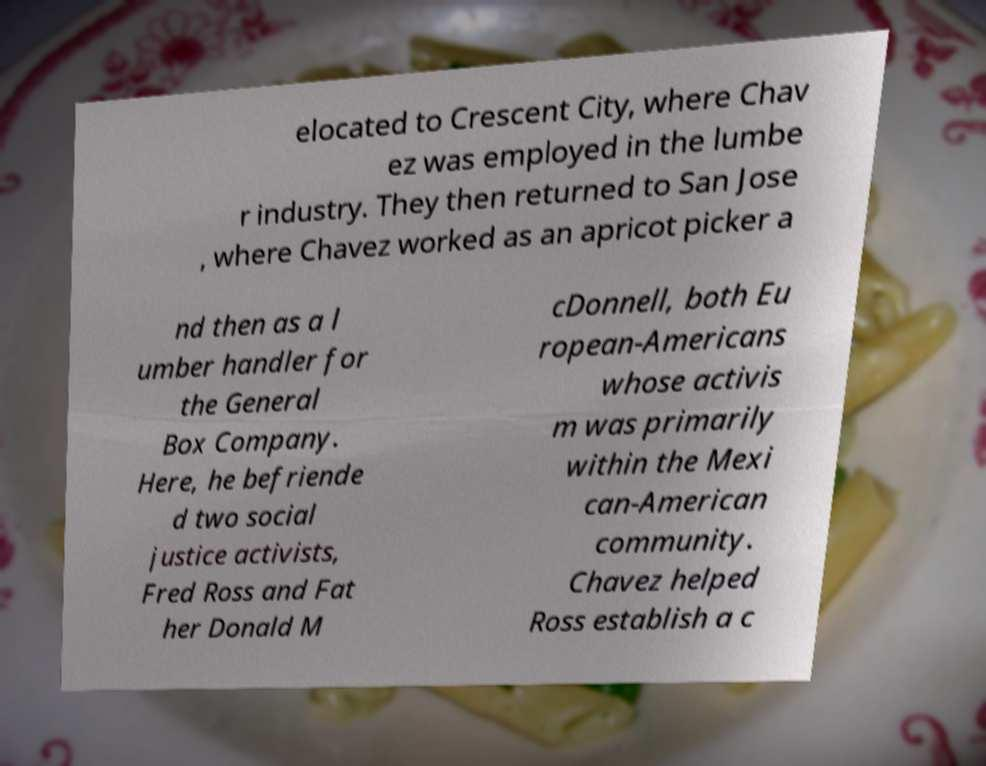For documentation purposes, I need the text within this image transcribed. Could you provide that? elocated to Crescent City, where Chav ez was employed in the lumbe r industry. They then returned to San Jose , where Chavez worked as an apricot picker a nd then as a l umber handler for the General Box Company. Here, he befriende d two social justice activists, Fred Ross and Fat her Donald M cDonnell, both Eu ropean-Americans whose activis m was primarily within the Mexi can-American community. Chavez helped Ross establish a c 